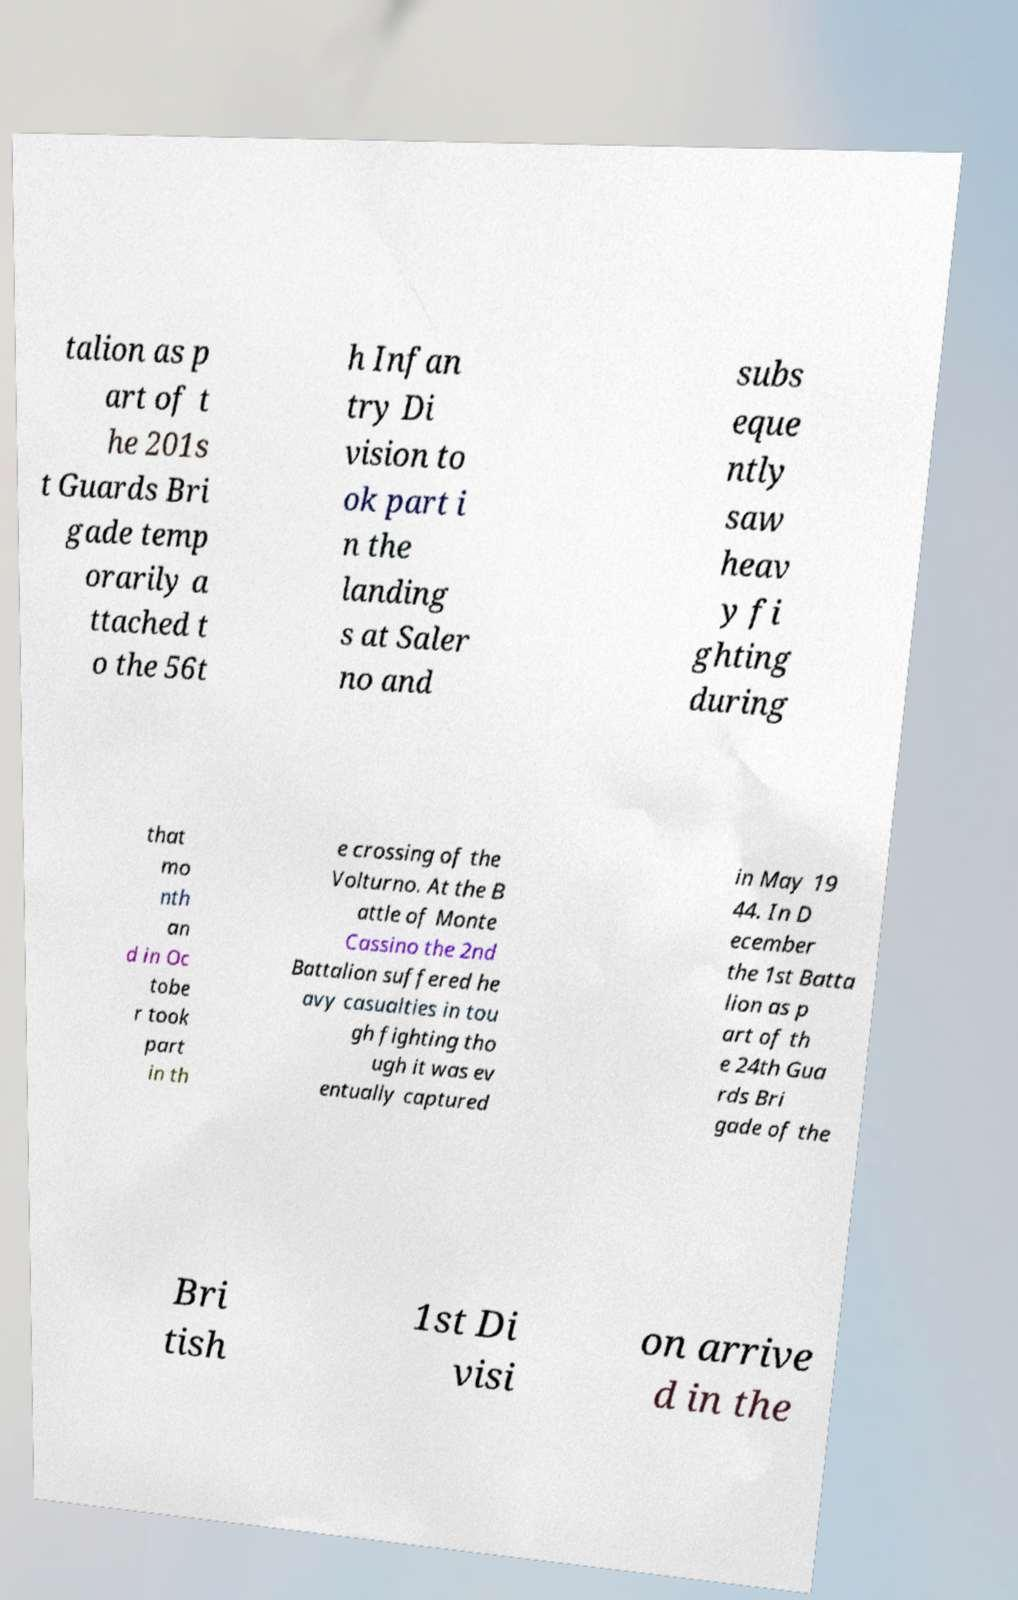Please read and relay the text visible in this image. What does it say? talion as p art of t he 201s t Guards Bri gade temp orarily a ttached t o the 56t h Infan try Di vision to ok part i n the landing s at Saler no and subs eque ntly saw heav y fi ghting during that mo nth an d in Oc tobe r took part in th e crossing of the Volturno. At the B attle of Monte Cassino the 2nd Battalion suffered he avy casualties in tou gh fighting tho ugh it was ev entually captured in May 19 44. In D ecember the 1st Batta lion as p art of th e 24th Gua rds Bri gade of the Bri tish 1st Di visi on arrive d in the 